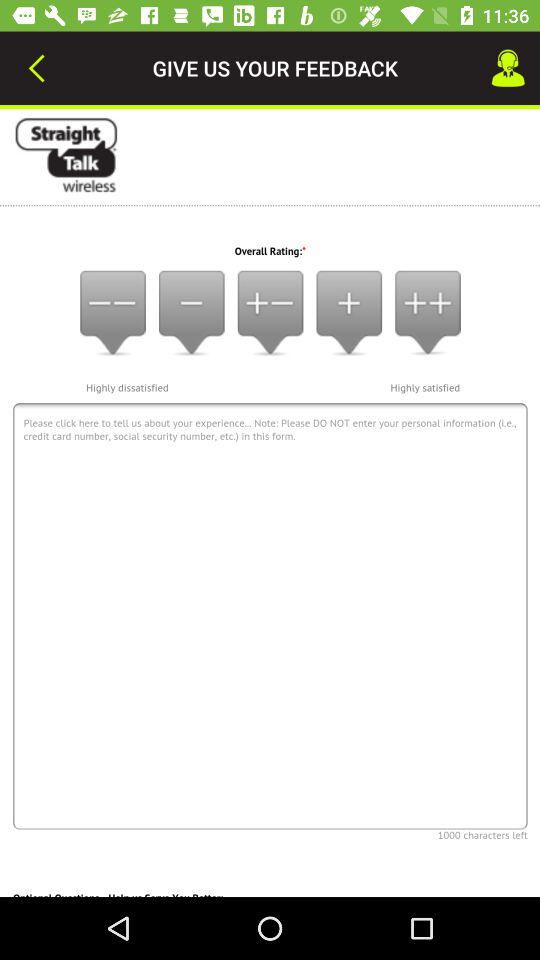What information should not be shared in this form? You should not share your personal information (i.e., credit card number, social security number, etc.). 